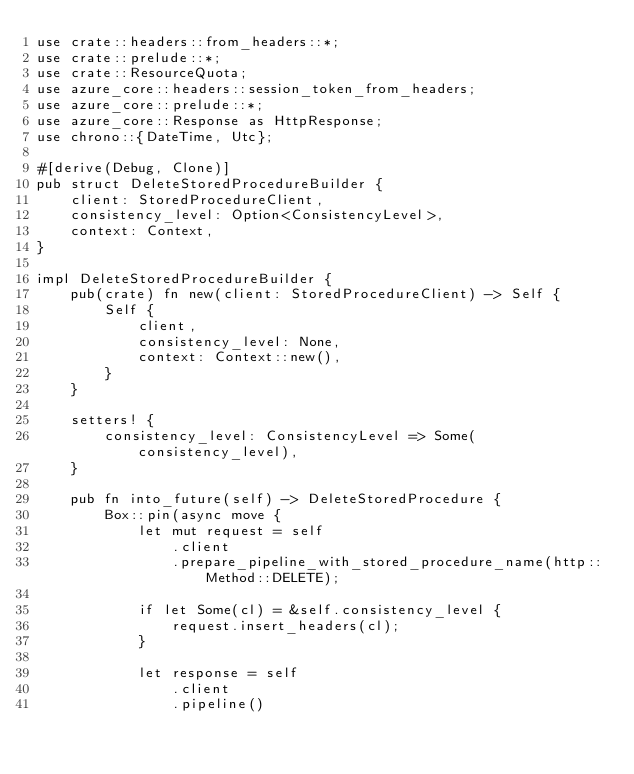Convert code to text. <code><loc_0><loc_0><loc_500><loc_500><_Rust_>use crate::headers::from_headers::*;
use crate::prelude::*;
use crate::ResourceQuota;
use azure_core::headers::session_token_from_headers;
use azure_core::prelude::*;
use azure_core::Response as HttpResponse;
use chrono::{DateTime, Utc};

#[derive(Debug, Clone)]
pub struct DeleteStoredProcedureBuilder {
    client: StoredProcedureClient,
    consistency_level: Option<ConsistencyLevel>,
    context: Context,
}

impl DeleteStoredProcedureBuilder {
    pub(crate) fn new(client: StoredProcedureClient) -> Self {
        Self {
            client,
            consistency_level: None,
            context: Context::new(),
        }
    }

    setters! {
        consistency_level: ConsistencyLevel => Some(consistency_level),
    }

    pub fn into_future(self) -> DeleteStoredProcedure {
        Box::pin(async move {
            let mut request = self
                .client
                .prepare_pipeline_with_stored_procedure_name(http::Method::DELETE);

            if let Some(cl) = &self.consistency_level {
                request.insert_headers(cl);
            }

            let response = self
                .client
                .pipeline()</code> 